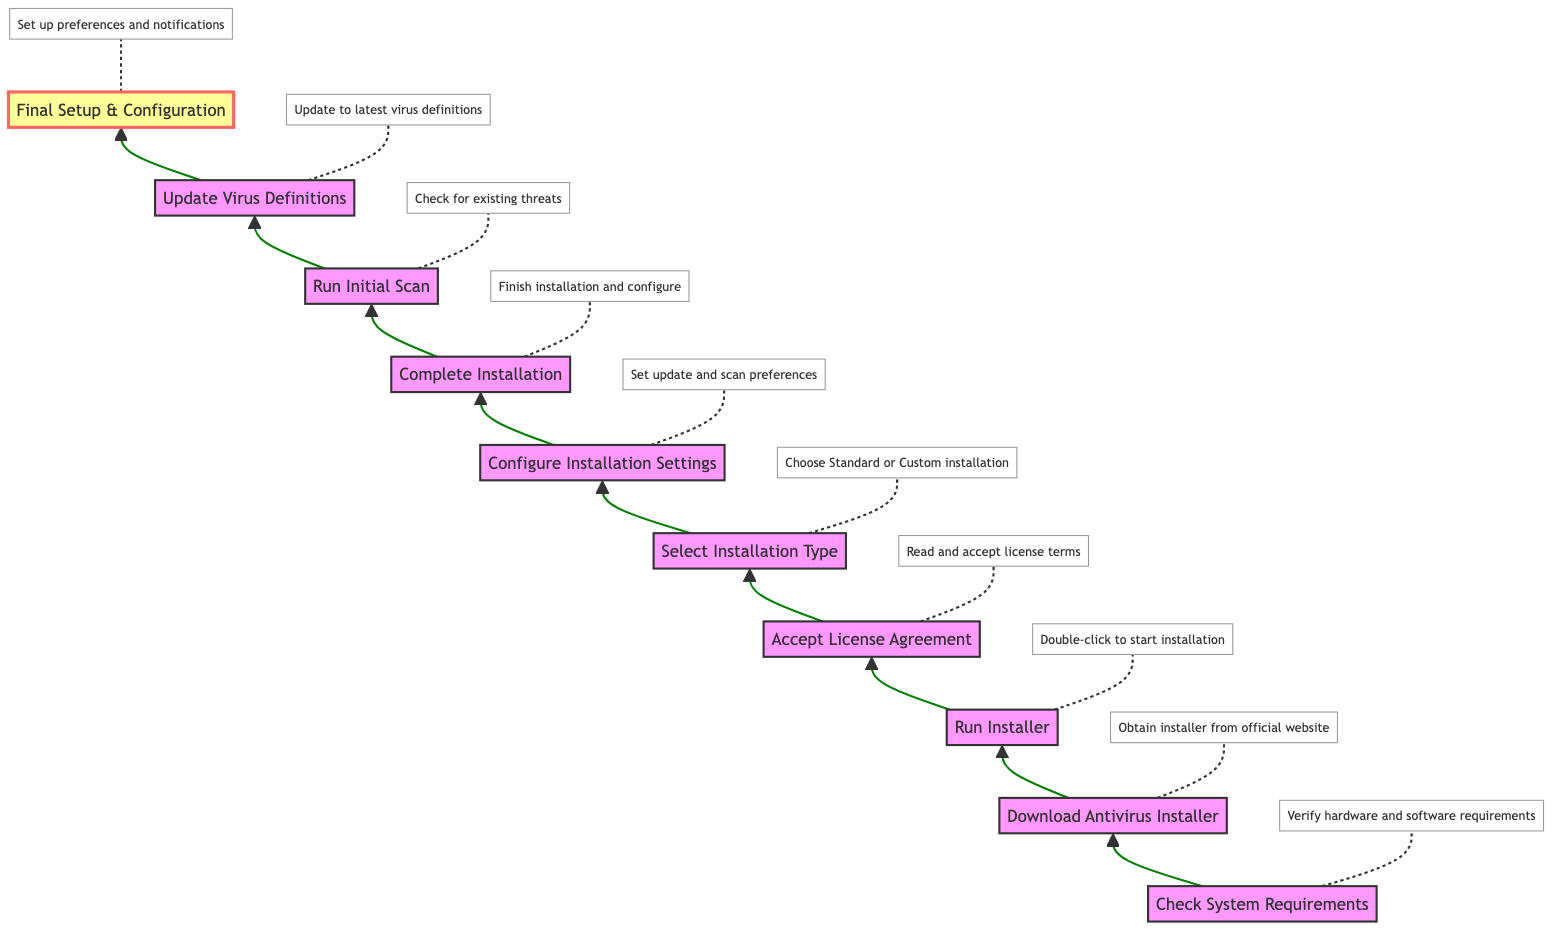What is the first step in the installation process? The first step in the installation process, as shown in the diagram, is "Check System Requirements." This is indicated as the starting node in the flow chart.
Answer: Check System Requirements How many steps are there in total? The total number of steps in the flow chart is counted from the starting node to the final setup. There are ten distinct steps listed in the diagram.
Answer: 10 What is the last step of the installation process? The last step of the installation process is labeled "Final Setup & Configuration." This is evident as it is the final node in the flowchart.
Answer: Final Setup & Configuration What is the relationship between "Download Antivirus Installer" and "Accept License Agreement"? The relationship is sequential; "Download Antivirus Installer" must be completed before you can "Accept License Agreement." This is clear in the flow from one step to the next in the diagram.
Answer: Sequential Which step requires reading a license agreement? The step that requires reading a license agreement is "Accept License Agreement." This is explicitly stated in the description for that step in the flow chart.
Answer: Accept License Agreement How many configuration-related steps are there in total? The configuration-related steps, based on the descriptions highlighted, include "Configure Installation Settings" and "Final Setup & Configuration." Therefore, there are two steps focused on configuration.
Answer: 2 Which steps involve updating? The steps that involve updating are "Update Virus Definitions" and "Configure Installation Settings," as both pertain to setting updates and ensuring the software is current.
Answer: Update Virus Definitions, Configure Installation Settings What type of installation can the user choose during the process? The user can choose between "Standard" or "Custom installation" during the "Select Installation Type" step, which outlines the options available for installation.
Answer: Standard, Custom What is the purpose of the "Run Initial Scan" step? The purpose of the "Run Initial Scan" step is to perform an initial check for existing threats. This is specifically mentioned in its description, highlighting its importance in the installation process.
Answer: Check for existing threats 